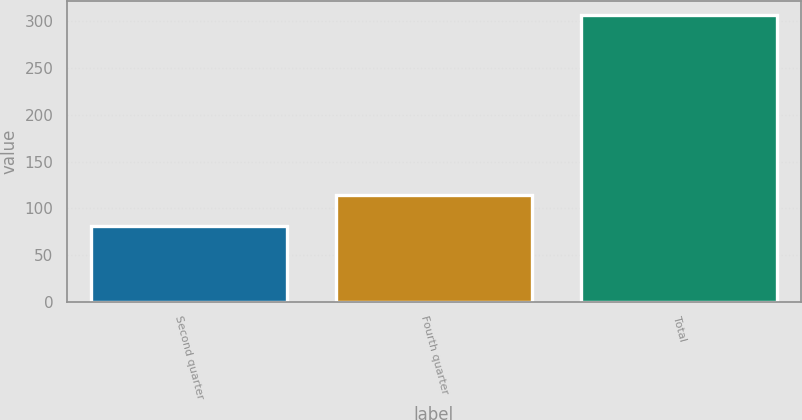<chart> <loc_0><loc_0><loc_500><loc_500><bar_chart><fcel>Second quarter<fcel>Fourth quarter<fcel>Total<nl><fcel>81<fcel>114<fcel>307<nl></chart> 